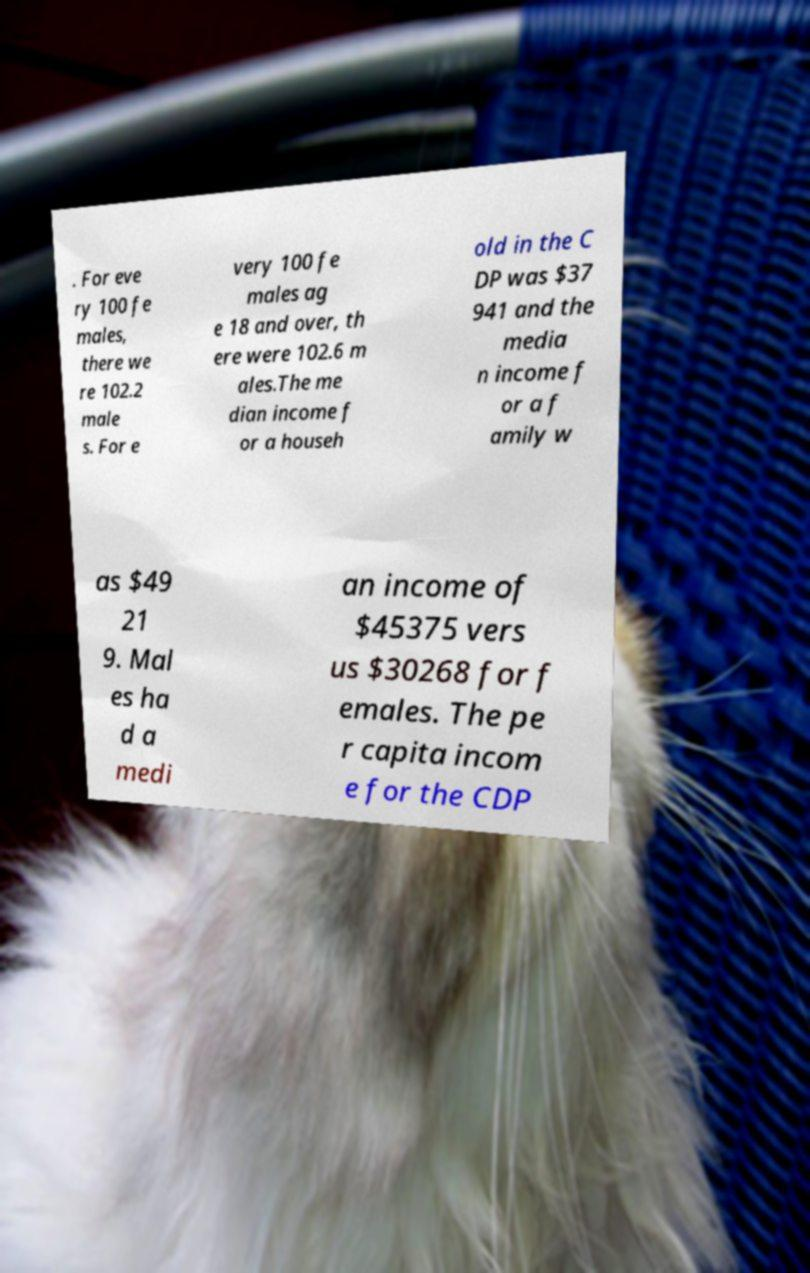Could you extract and type out the text from this image? . For eve ry 100 fe males, there we re 102.2 male s. For e very 100 fe males ag e 18 and over, th ere were 102.6 m ales.The me dian income f or a househ old in the C DP was $37 941 and the media n income f or a f amily w as $49 21 9. Mal es ha d a medi an income of $45375 vers us $30268 for f emales. The pe r capita incom e for the CDP 